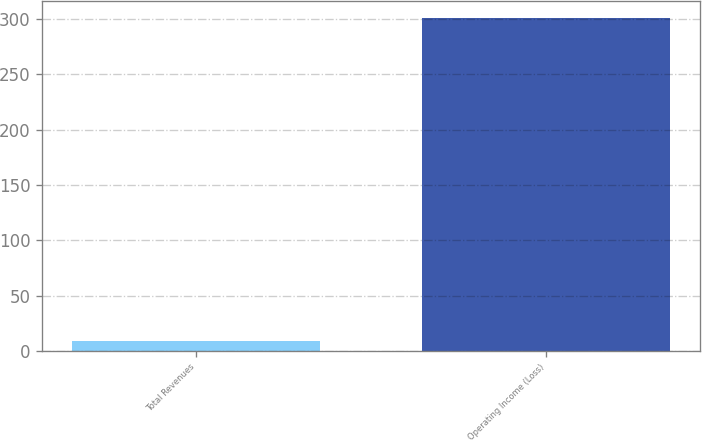<chart> <loc_0><loc_0><loc_500><loc_500><bar_chart><fcel>Total Revenues<fcel>Operating Income (Loss)<nl><fcel>9<fcel>301<nl></chart> 